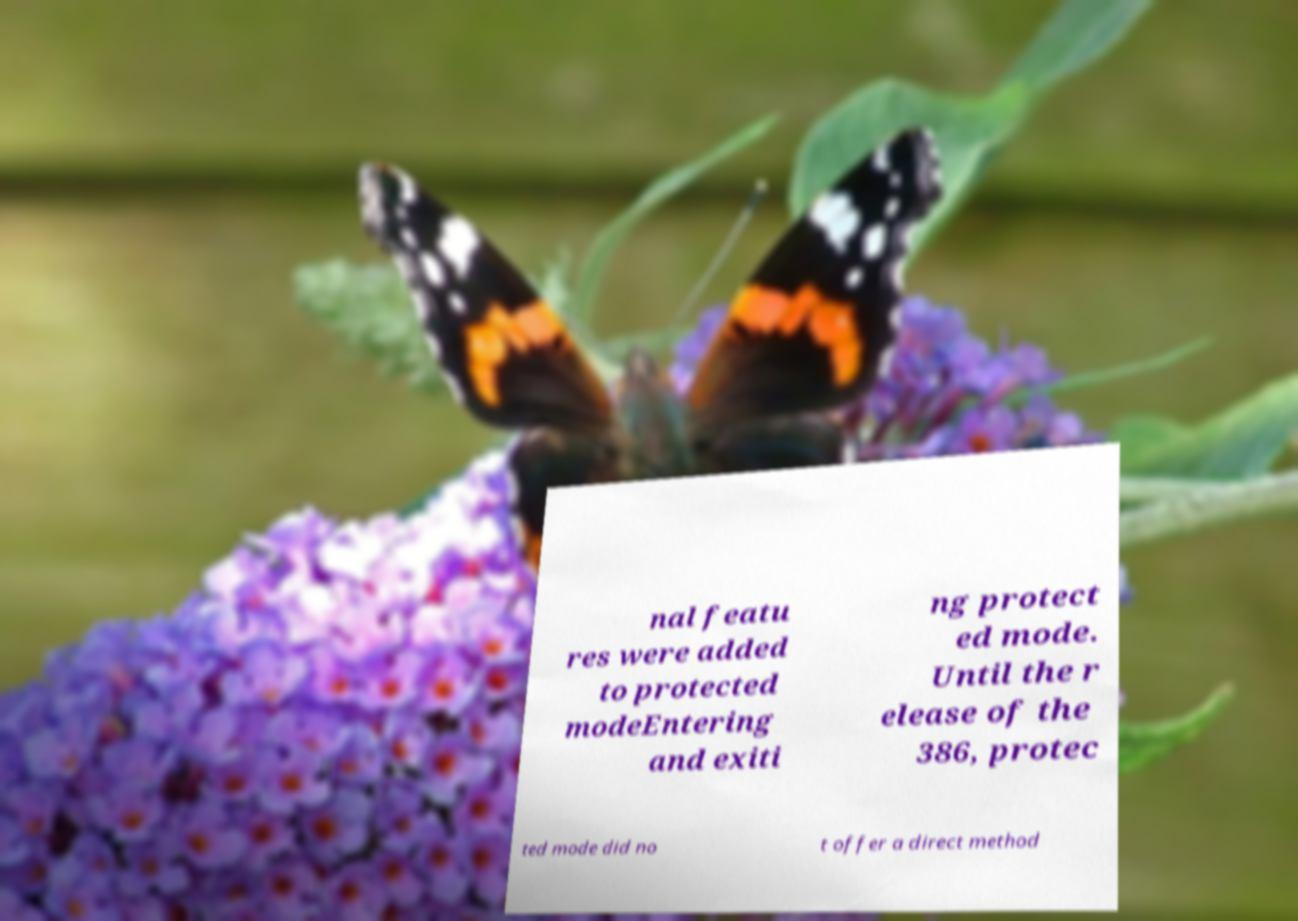What messages or text are displayed in this image? I need them in a readable, typed format. nal featu res were added to protected modeEntering and exiti ng protect ed mode. Until the r elease of the 386, protec ted mode did no t offer a direct method 